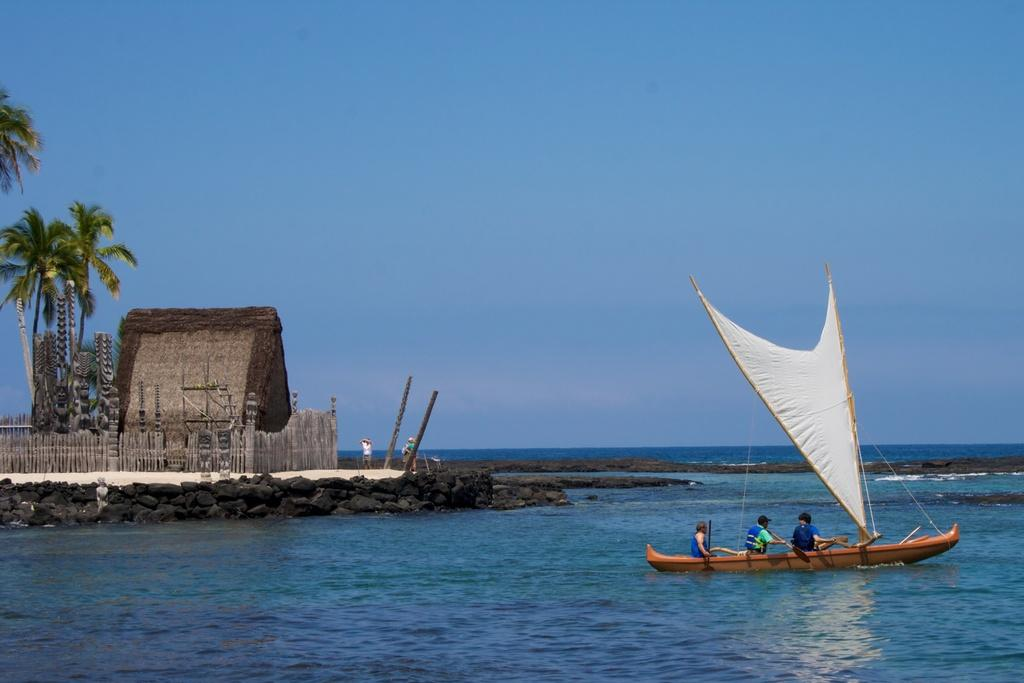How many people can be seen in the image? There are people in the image, but the exact number is not specified. What type of terrain is visible in the image? There is ground visible in the image. What type of structure is present in the image? There is a hut in the image. What type of barrier is present in the image? There is fencing in the image. What type of vertical structures are present in the image? There are poles in the image. What type of vegetation is visible in the image? There are trees in the image. What type of watercraft is present in the image? There is a water boat in the image. What activity are some people engaged in within the image? Some people are sailing in a boat. What part of the natural environment is visible in the image? The sky is visible in the image. Where is the governor sitting in the image? There is no governor present in the image. What type of chicken can be seen in the image? There are no chickens present in the image. What type of pump is visible in the image? There is no pump present in the image. 